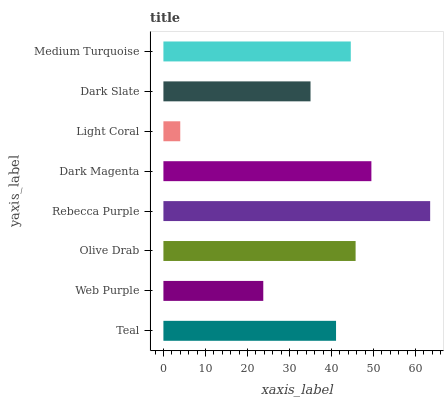Is Light Coral the minimum?
Answer yes or no. Yes. Is Rebecca Purple the maximum?
Answer yes or no. Yes. Is Web Purple the minimum?
Answer yes or no. No. Is Web Purple the maximum?
Answer yes or no. No. Is Teal greater than Web Purple?
Answer yes or no. Yes. Is Web Purple less than Teal?
Answer yes or no. Yes. Is Web Purple greater than Teal?
Answer yes or no. No. Is Teal less than Web Purple?
Answer yes or no. No. Is Medium Turquoise the high median?
Answer yes or no. Yes. Is Teal the low median?
Answer yes or no. Yes. Is Olive Drab the high median?
Answer yes or no. No. Is Dark Slate the low median?
Answer yes or no. No. 